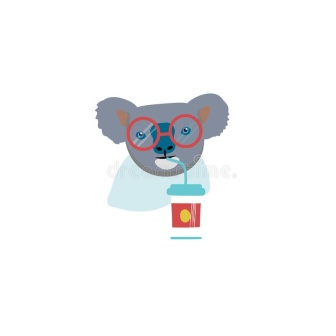What might the koala be thinking while drinking from the cup? The koala might be thinking about the refreshing taste of the drink or perhaps enjoying a moment of relaxation. Its expression, along with the casual posture of holding the cup, suggests a content and leisurely demeanor, reflecting a break from the day's routines. 